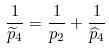<formula> <loc_0><loc_0><loc_500><loc_500>\frac { 1 } { \widetilde { p } _ { 4 } } = \frac { 1 } { p _ { 2 } } + \frac { 1 } { \widehat { p } _ { 4 } }</formula> 